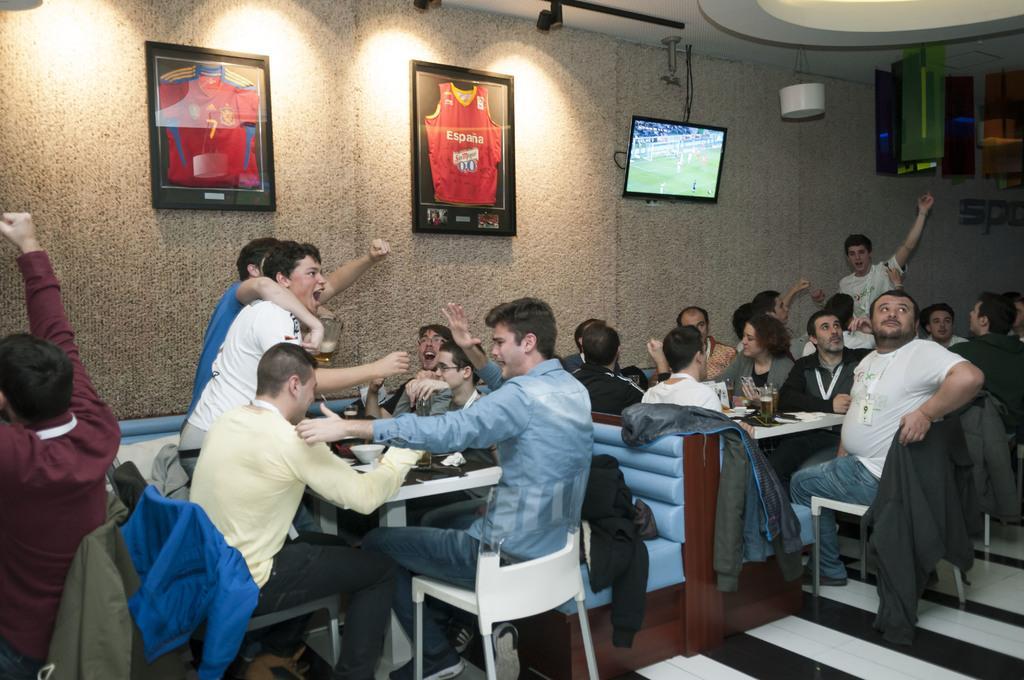In one or two sentences, can you explain what this image depicts? In this image we have a group of people who are sitting on the chair in front of the table. On the wall we have a TV, a wall photo on it. On the table we have a few objects on it. 